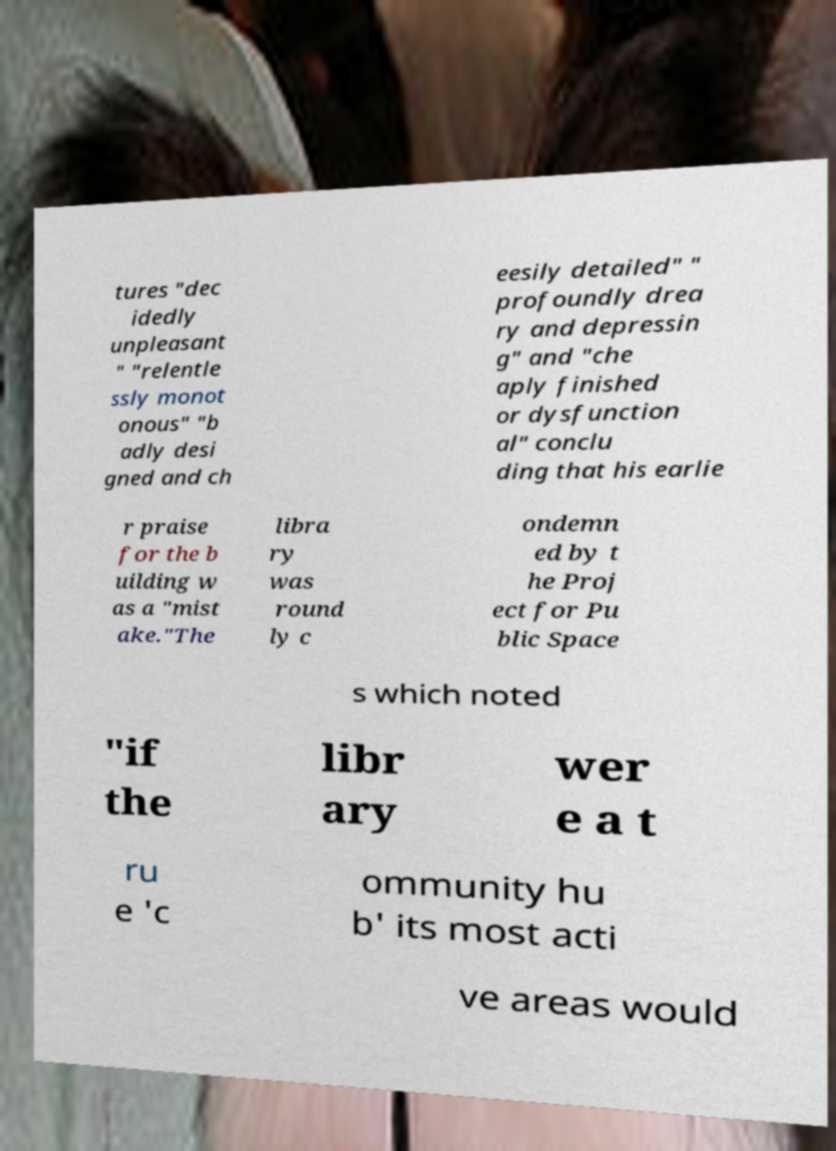I need the written content from this picture converted into text. Can you do that? tures "dec idedly unpleasant " "relentle ssly monot onous" "b adly desi gned and ch eesily detailed" " profoundly drea ry and depressin g" and "che aply finished or dysfunction al" conclu ding that his earlie r praise for the b uilding w as a "mist ake."The libra ry was round ly c ondemn ed by t he Proj ect for Pu blic Space s which noted "if the libr ary wer e a t ru e 'c ommunity hu b' its most acti ve areas would 